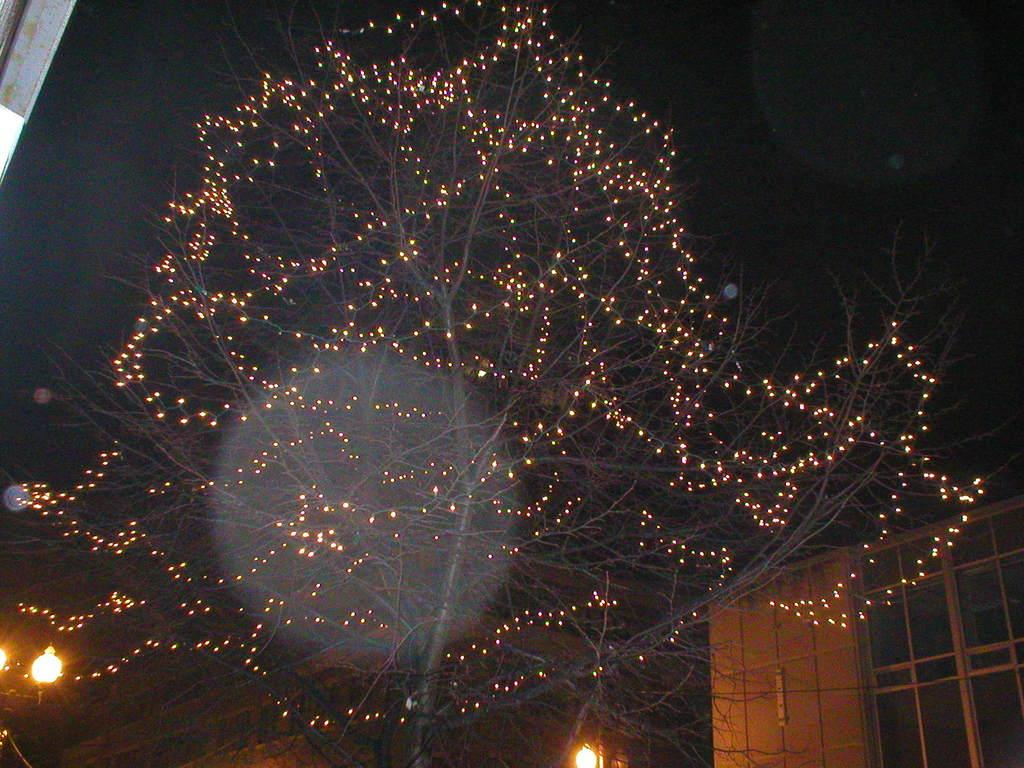What type of natural element is present in the image? There is a tree in the image. What is added to the tree to make it stand out? There are lights on the tree. What type of artificial lighting can be seen in the image? There are street lights in the image. What type of man-made structures are visible in the image? There are buildings in the image. What is the color of the sky in the background of the image? The sky is dark in the background of the image. How many cakes are being baked on the stove in the image? There are no cakes or stoves present in the image. What type of light is emitted from the light bulb in the image? There is no light bulb present in the image. 